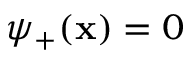Convert formula to latex. <formula><loc_0><loc_0><loc_500><loc_500>\psi _ { + } ( x ) = 0</formula> 